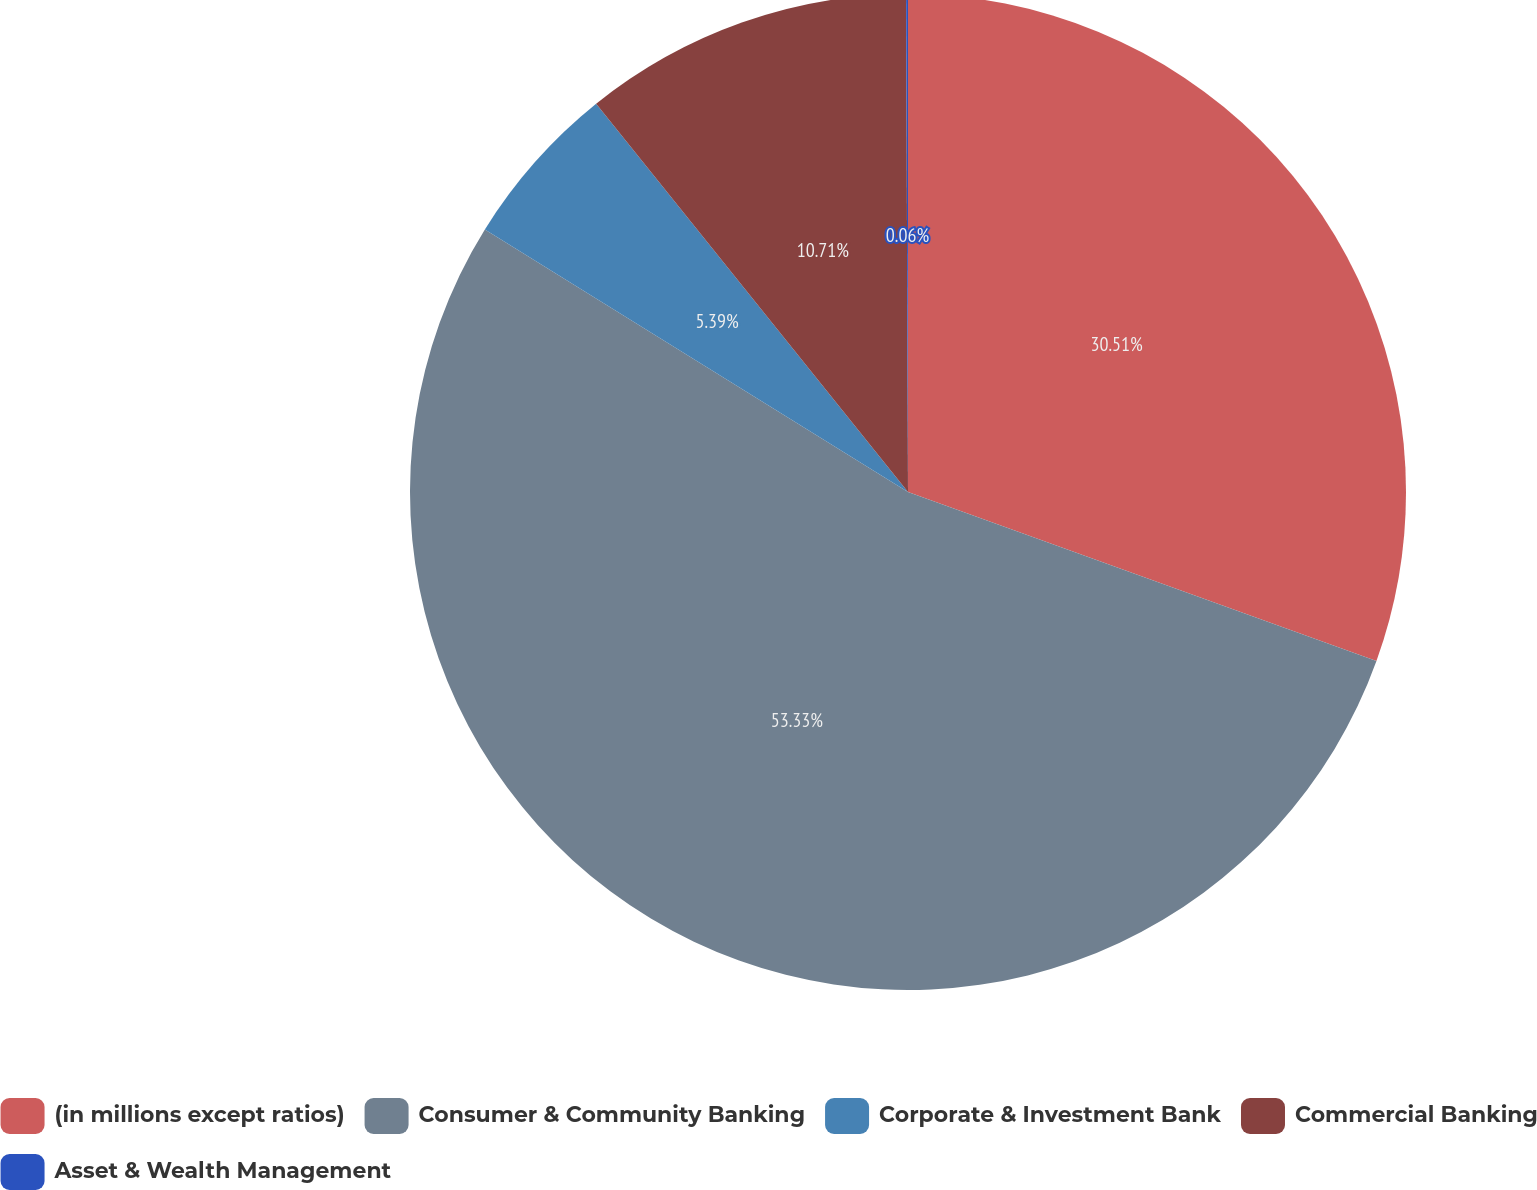Convert chart to OTSL. <chart><loc_0><loc_0><loc_500><loc_500><pie_chart><fcel>(in millions except ratios)<fcel>Consumer & Community Banking<fcel>Corporate & Investment Bank<fcel>Commercial Banking<fcel>Asset & Wealth Management<nl><fcel>30.51%<fcel>53.33%<fcel>5.39%<fcel>10.71%<fcel>0.06%<nl></chart> 